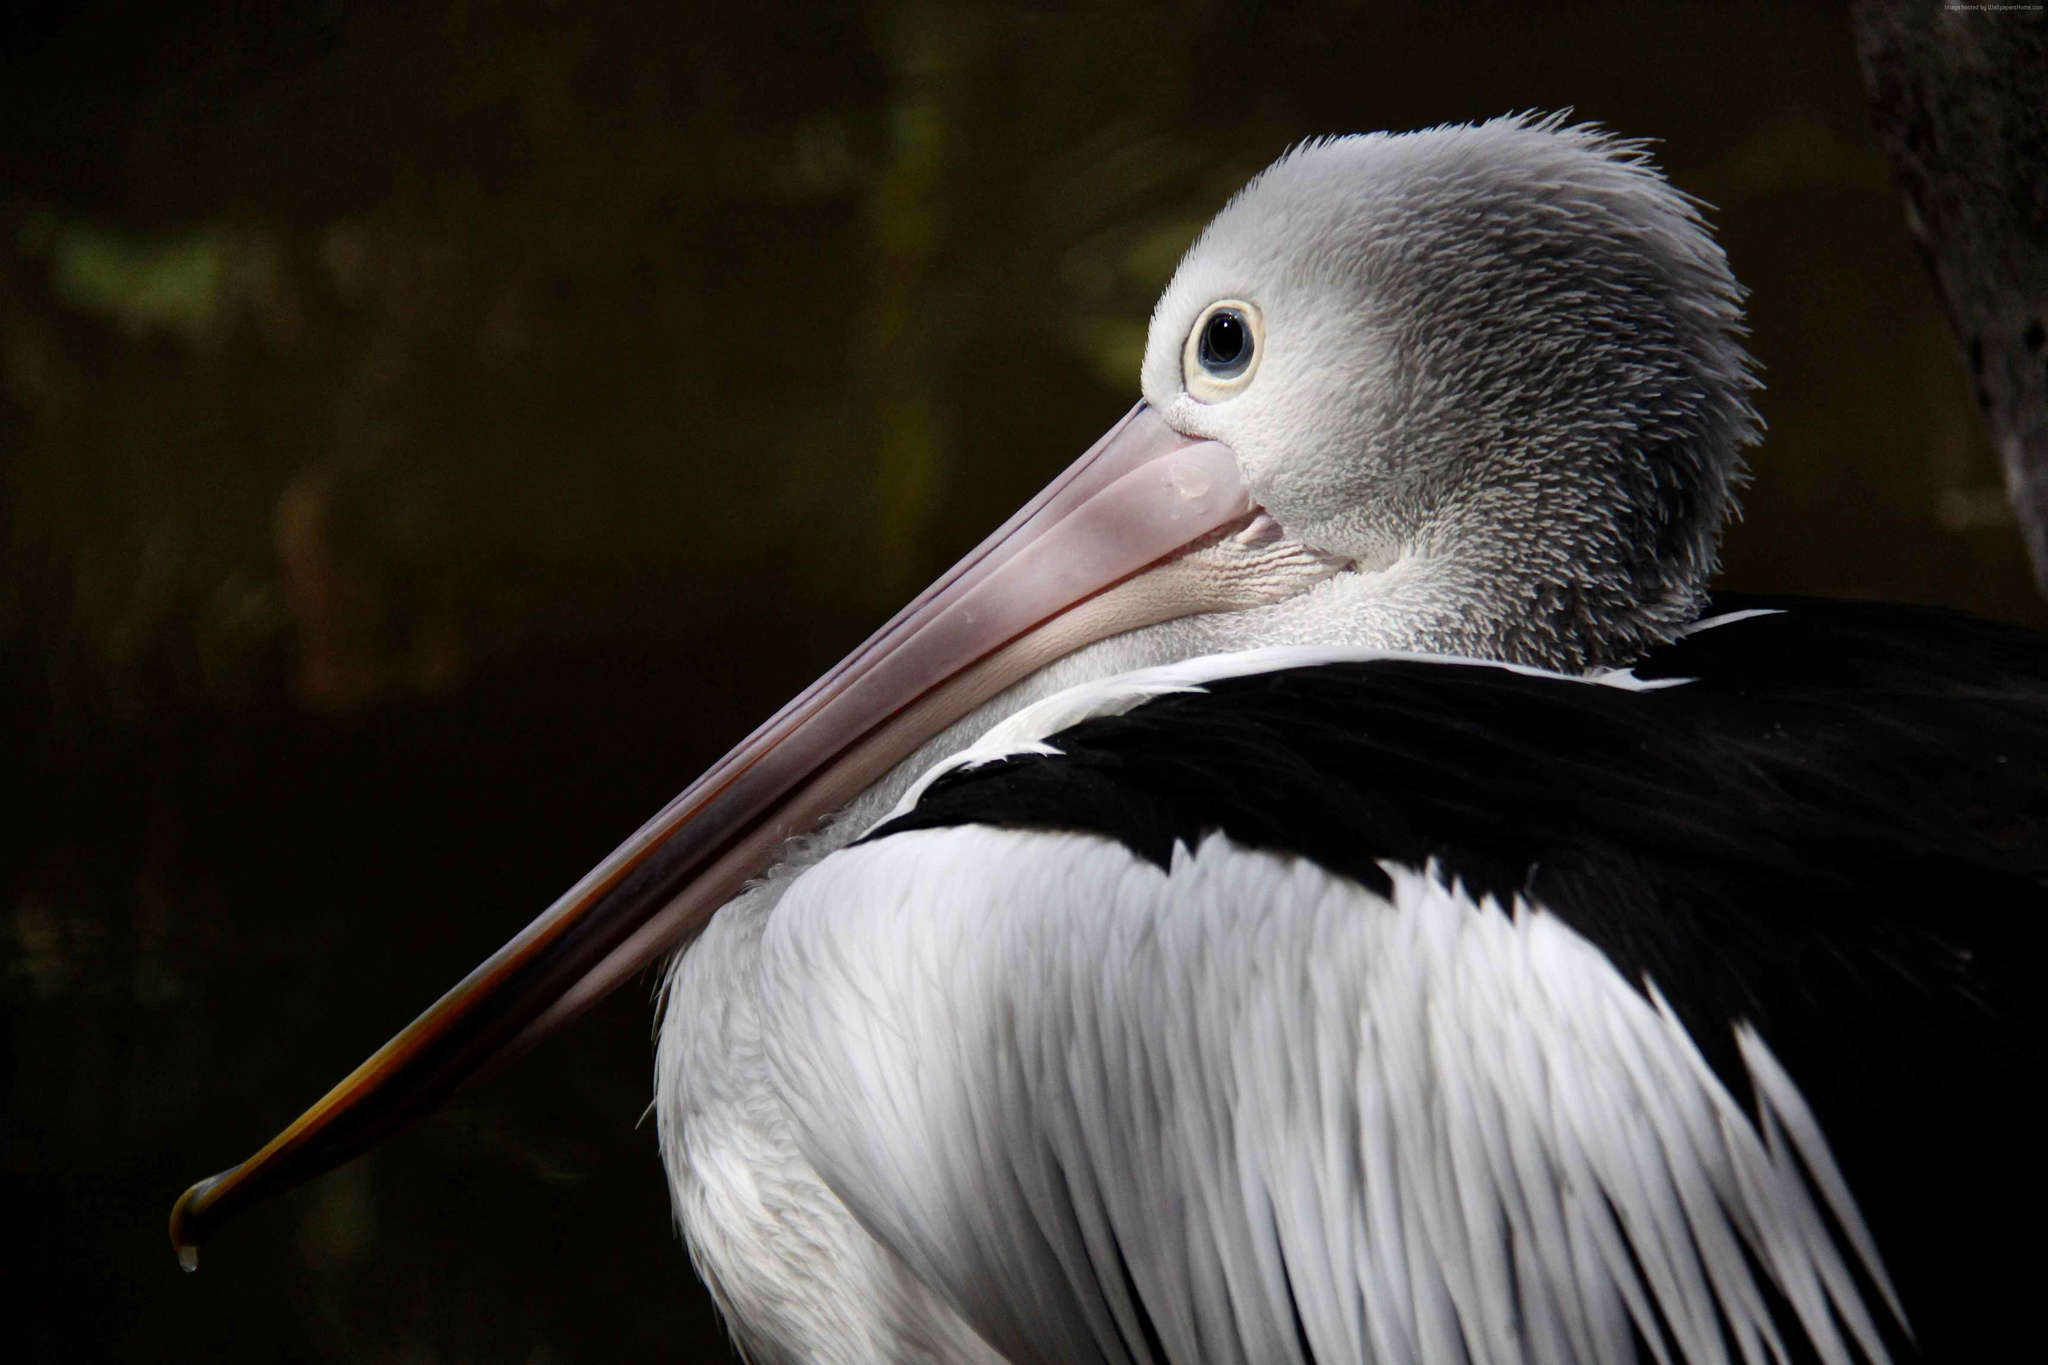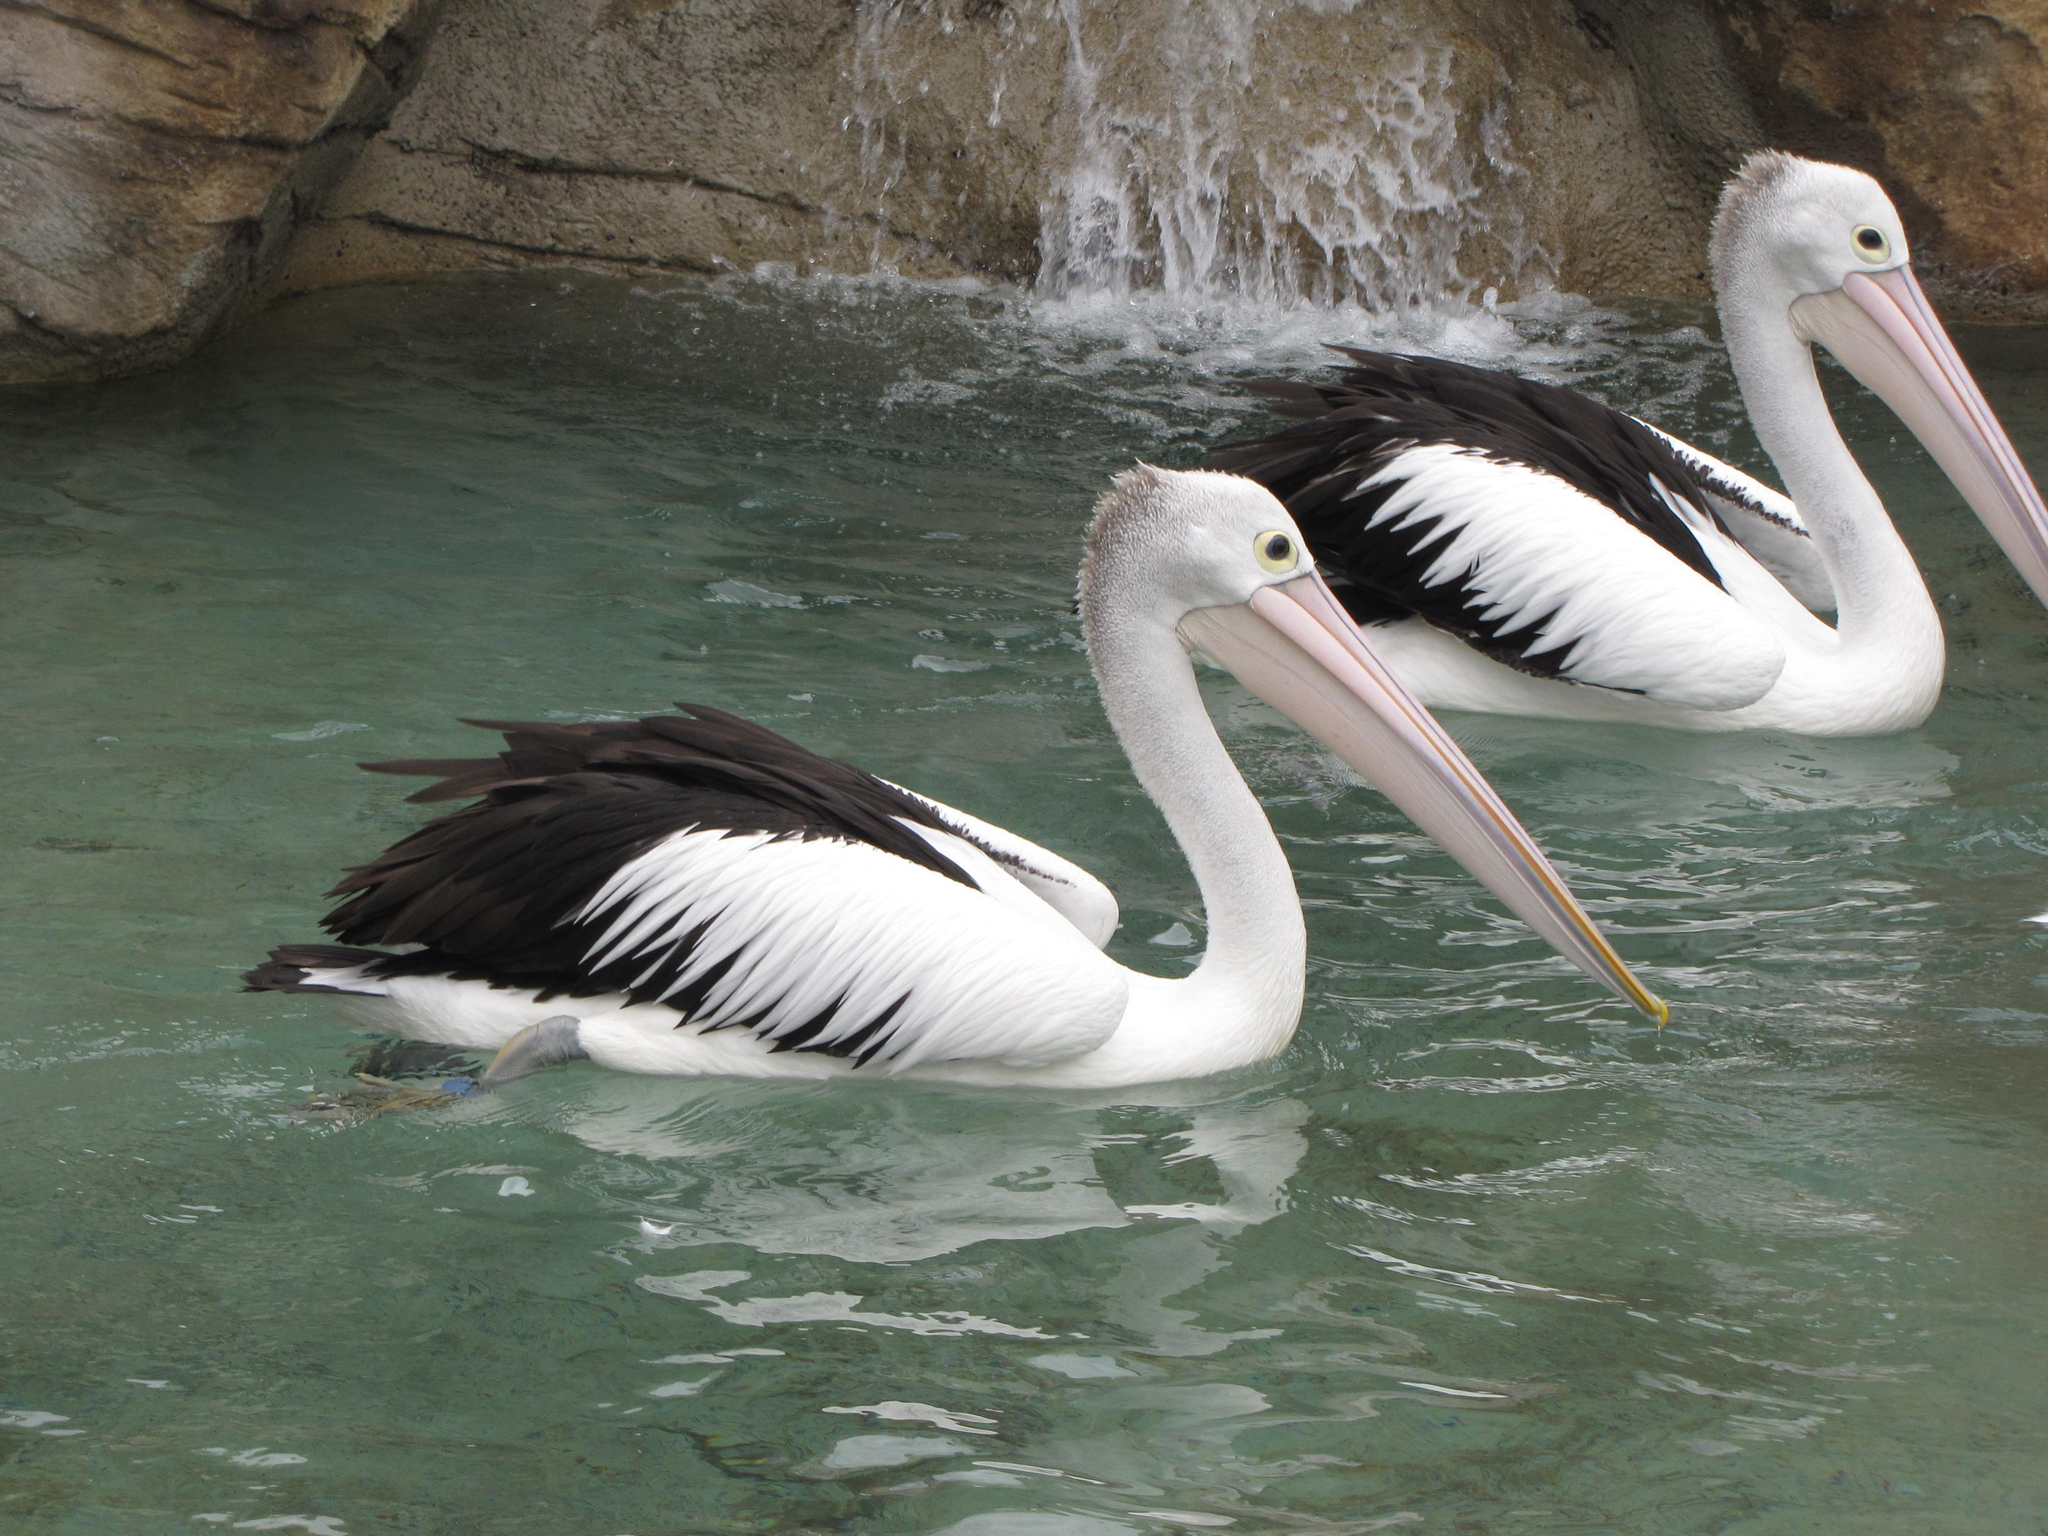The first image is the image on the left, the second image is the image on the right. Analyze the images presented: Is the assertion "One of the images contains exactly two birds." valid? Answer yes or no. Yes. 